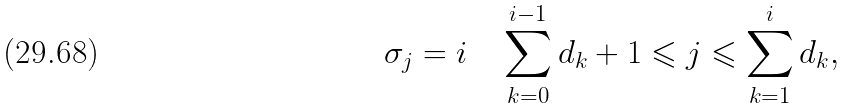Convert formula to latex. <formula><loc_0><loc_0><loc_500><loc_500>\sigma _ { j } = i \quad \sum _ { k = 0 } ^ { i - 1 } d _ { k } + 1 \leqslant j \leqslant \sum _ { k = 1 } ^ { i } d _ { k } ,</formula> 